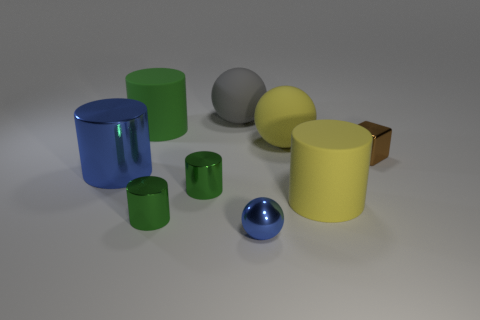Does the yellow cylinder have the same size as the blue ball?
Your answer should be compact. No. Is the number of gray spheres that are behind the large gray ball less than the number of big balls that are in front of the yellow rubber sphere?
Give a very brief answer. No. Are there any other things that are the same size as the brown cube?
Your response must be concise. Yes. What size is the blue ball?
Give a very brief answer. Small. What number of small objects are gray objects or rubber cylinders?
Make the answer very short. 0. Do the green matte cylinder and the blue ball to the left of the yellow matte cylinder have the same size?
Give a very brief answer. No. Are there any other things that have the same shape as the big blue thing?
Offer a very short reply. Yes. What number of large blue things are there?
Give a very brief answer. 1. What number of gray things are small shiny objects or balls?
Your answer should be compact. 1. Do the tiny object to the right of the big yellow matte ball and the large green thing have the same material?
Provide a succinct answer. No. 